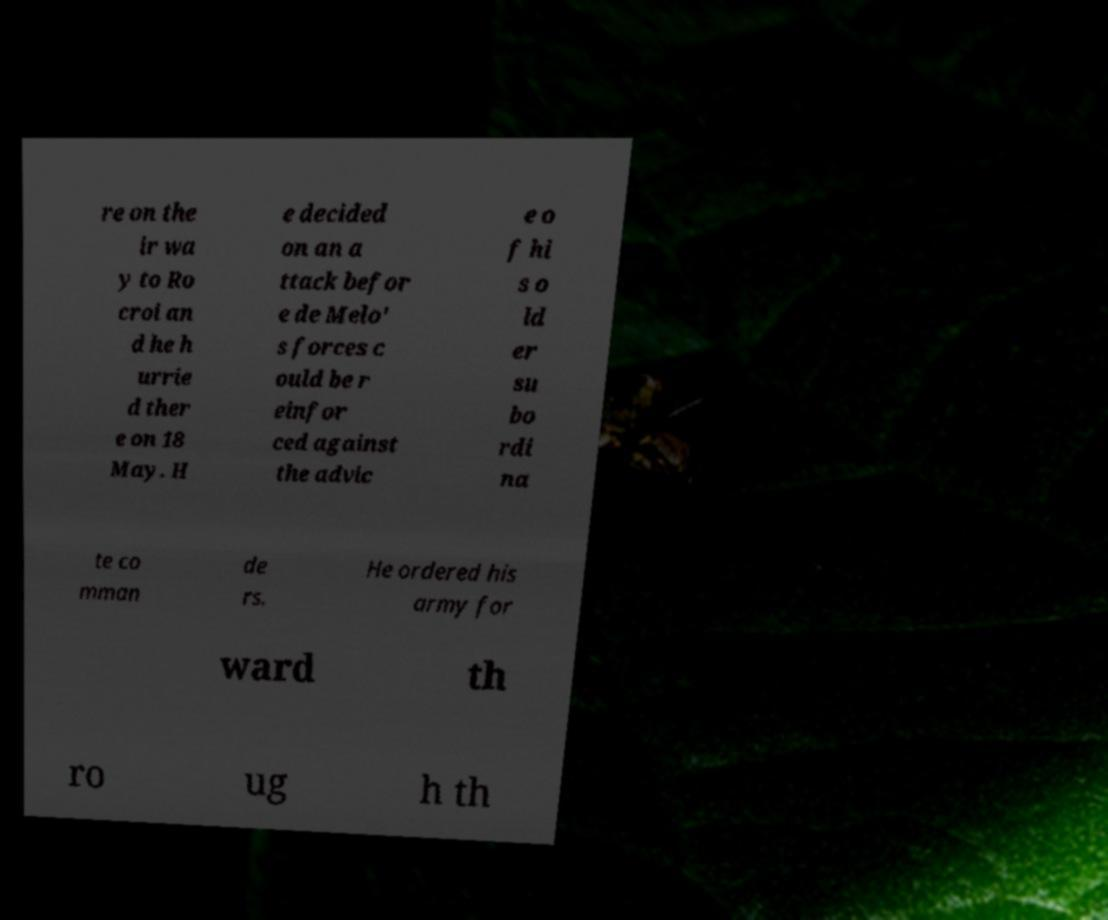What messages or text are displayed in this image? I need them in a readable, typed format. re on the ir wa y to Ro croi an d he h urrie d ther e on 18 May. H e decided on an a ttack befor e de Melo' s forces c ould be r einfor ced against the advic e o f hi s o ld er su bo rdi na te co mman de rs. He ordered his army for ward th ro ug h th 